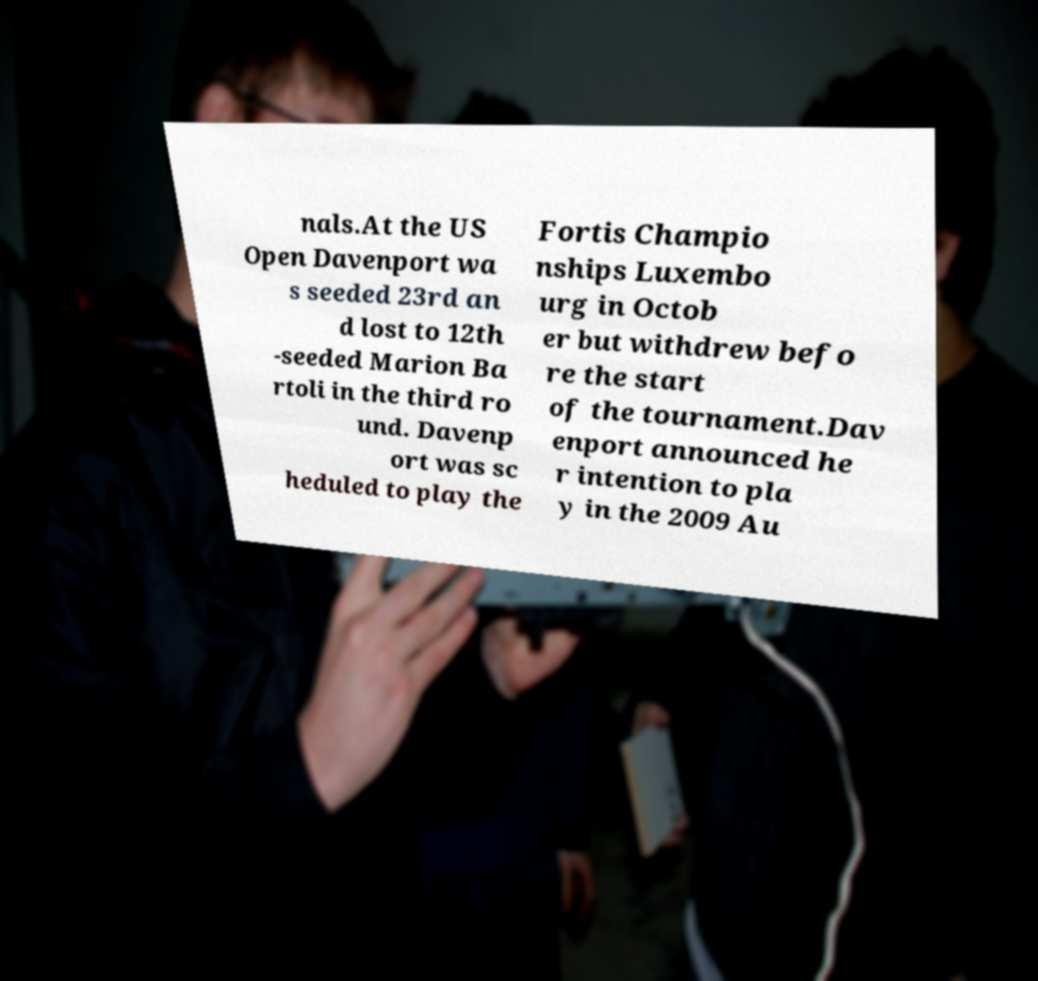What messages or text are displayed in this image? I need them in a readable, typed format. nals.At the US Open Davenport wa s seeded 23rd an d lost to 12th -seeded Marion Ba rtoli in the third ro und. Davenp ort was sc heduled to play the Fortis Champio nships Luxembo urg in Octob er but withdrew befo re the start of the tournament.Dav enport announced he r intention to pla y in the 2009 Au 